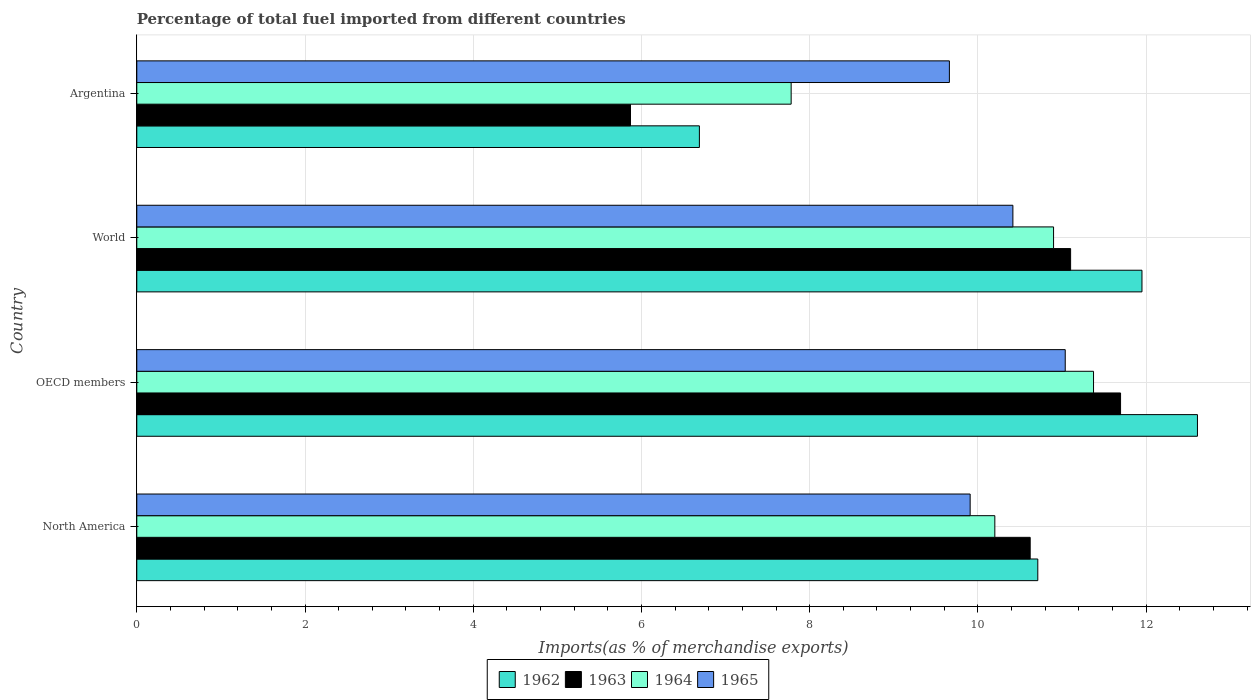How many groups of bars are there?
Your response must be concise. 4. Are the number of bars per tick equal to the number of legend labels?
Give a very brief answer. Yes. Are the number of bars on each tick of the Y-axis equal?
Provide a succinct answer. Yes. How many bars are there on the 1st tick from the top?
Provide a short and direct response. 4. How many bars are there on the 3rd tick from the bottom?
Keep it short and to the point. 4. What is the label of the 1st group of bars from the top?
Your answer should be very brief. Argentina. In how many cases, is the number of bars for a given country not equal to the number of legend labels?
Make the answer very short. 0. What is the percentage of imports to different countries in 1962 in OECD members?
Your answer should be very brief. 12.61. Across all countries, what is the maximum percentage of imports to different countries in 1962?
Your answer should be very brief. 12.61. Across all countries, what is the minimum percentage of imports to different countries in 1962?
Offer a terse response. 6.69. What is the total percentage of imports to different countries in 1965 in the graph?
Your answer should be very brief. 41.02. What is the difference between the percentage of imports to different countries in 1963 in OECD members and that in World?
Provide a succinct answer. 0.59. What is the difference between the percentage of imports to different countries in 1962 in Argentina and the percentage of imports to different countries in 1963 in World?
Keep it short and to the point. -4.41. What is the average percentage of imports to different countries in 1965 per country?
Offer a terse response. 10.26. What is the difference between the percentage of imports to different countries in 1964 and percentage of imports to different countries in 1965 in World?
Offer a very short reply. 0.48. In how many countries, is the percentage of imports to different countries in 1965 greater than 7.6 %?
Provide a short and direct response. 4. What is the ratio of the percentage of imports to different countries in 1962 in OECD members to that in World?
Keep it short and to the point. 1.06. Is the percentage of imports to different countries in 1962 in OECD members less than that in World?
Offer a terse response. No. What is the difference between the highest and the second highest percentage of imports to different countries in 1962?
Offer a very short reply. 0.66. What is the difference between the highest and the lowest percentage of imports to different countries in 1964?
Provide a short and direct response. 3.59. In how many countries, is the percentage of imports to different countries in 1965 greater than the average percentage of imports to different countries in 1965 taken over all countries?
Keep it short and to the point. 2. What does the 2nd bar from the top in North America represents?
Keep it short and to the point. 1964. What does the 3rd bar from the bottom in Argentina represents?
Your answer should be very brief. 1964. Is it the case that in every country, the sum of the percentage of imports to different countries in 1962 and percentage of imports to different countries in 1964 is greater than the percentage of imports to different countries in 1965?
Offer a very short reply. Yes. How many countries are there in the graph?
Offer a terse response. 4. What is the difference between two consecutive major ticks on the X-axis?
Keep it short and to the point. 2. Does the graph contain grids?
Your response must be concise. Yes. How many legend labels are there?
Keep it short and to the point. 4. What is the title of the graph?
Your response must be concise. Percentage of total fuel imported from different countries. Does "1984" appear as one of the legend labels in the graph?
Give a very brief answer. No. What is the label or title of the X-axis?
Ensure brevity in your answer.  Imports(as % of merchandise exports). What is the Imports(as % of merchandise exports) of 1962 in North America?
Offer a terse response. 10.71. What is the Imports(as % of merchandise exports) in 1963 in North America?
Offer a very short reply. 10.62. What is the Imports(as % of merchandise exports) in 1964 in North America?
Your response must be concise. 10.2. What is the Imports(as % of merchandise exports) of 1965 in North America?
Make the answer very short. 9.91. What is the Imports(as % of merchandise exports) in 1962 in OECD members?
Make the answer very short. 12.61. What is the Imports(as % of merchandise exports) in 1963 in OECD members?
Keep it short and to the point. 11.7. What is the Imports(as % of merchandise exports) in 1964 in OECD members?
Offer a very short reply. 11.37. What is the Imports(as % of merchandise exports) of 1965 in OECD members?
Your answer should be very brief. 11.04. What is the Imports(as % of merchandise exports) in 1962 in World?
Provide a short and direct response. 11.95. What is the Imports(as % of merchandise exports) in 1963 in World?
Give a very brief answer. 11.1. What is the Imports(as % of merchandise exports) in 1964 in World?
Provide a short and direct response. 10.9. What is the Imports(as % of merchandise exports) in 1965 in World?
Your answer should be very brief. 10.42. What is the Imports(as % of merchandise exports) in 1962 in Argentina?
Your answer should be compact. 6.69. What is the Imports(as % of merchandise exports) of 1963 in Argentina?
Your response must be concise. 5.87. What is the Imports(as % of merchandise exports) in 1964 in Argentina?
Provide a short and direct response. 7.78. What is the Imports(as % of merchandise exports) in 1965 in Argentina?
Provide a short and direct response. 9.66. Across all countries, what is the maximum Imports(as % of merchandise exports) of 1962?
Your answer should be compact. 12.61. Across all countries, what is the maximum Imports(as % of merchandise exports) in 1963?
Give a very brief answer. 11.7. Across all countries, what is the maximum Imports(as % of merchandise exports) in 1964?
Your answer should be compact. 11.37. Across all countries, what is the maximum Imports(as % of merchandise exports) of 1965?
Provide a succinct answer. 11.04. Across all countries, what is the minimum Imports(as % of merchandise exports) of 1962?
Provide a short and direct response. 6.69. Across all countries, what is the minimum Imports(as % of merchandise exports) of 1963?
Offer a terse response. 5.87. Across all countries, what is the minimum Imports(as % of merchandise exports) of 1964?
Your answer should be compact. 7.78. Across all countries, what is the minimum Imports(as % of merchandise exports) in 1965?
Your answer should be very brief. 9.66. What is the total Imports(as % of merchandise exports) in 1962 in the graph?
Offer a terse response. 41.96. What is the total Imports(as % of merchandise exports) in 1963 in the graph?
Ensure brevity in your answer.  39.29. What is the total Imports(as % of merchandise exports) in 1964 in the graph?
Provide a succinct answer. 40.25. What is the total Imports(as % of merchandise exports) of 1965 in the graph?
Your answer should be compact. 41.02. What is the difference between the Imports(as % of merchandise exports) of 1962 in North America and that in OECD members?
Keep it short and to the point. -1.9. What is the difference between the Imports(as % of merchandise exports) of 1963 in North America and that in OECD members?
Your answer should be very brief. -1.07. What is the difference between the Imports(as % of merchandise exports) in 1964 in North America and that in OECD members?
Offer a very short reply. -1.17. What is the difference between the Imports(as % of merchandise exports) in 1965 in North America and that in OECD members?
Your answer should be compact. -1.13. What is the difference between the Imports(as % of merchandise exports) in 1962 in North America and that in World?
Your answer should be very brief. -1.24. What is the difference between the Imports(as % of merchandise exports) in 1963 in North America and that in World?
Offer a very short reply. -0.48. What is the difference between the Imports(as % of merchandise exports) in 1964 in North America and that in World?
Provide a succinct answer. -0.7. What is the difference between the Imports(as % of merchandise exports) of 1965 in North America and that in World?
Keep it short and to the point. -0.51. What is the difference between the Imports(as % of merchandise exports) of 1962 in North America and that in Argentina?
Provide a short and direct response. 4.02. What is the difference between the Imports(as % of merchandise exports) in 1963 in North America and that in Argentina?
Ensure brevity in your answer.  4.75. What is the difference between the Imports(as % of merchandise exports) of 1964 in North America and that in Argentina?
Provide a succinct answer. 2.42. What is the difference between the Imports(as % of merchandise exports) in 1965 in North America and that in Argentina?
Offer a terse response. 0.25. What is the difference between the Imports(as % of merchandise exports) of 1962 in OECD members and that in World?
Give a very brief answer. 0.66. What is the difference between the Imports(as % of merchandise exports) of 1963 in OECD members and that in World?
Make the answer very short. 0.59. What is the difference between the Imports(as % of merchandise exports) in 1964 in OECD members and that in World?
Ensure brevity in your answer.  0.48. What is the difference between the Imports(as % of merchandise exports) in 1965 in OECD members and that in World?
Provide a succinct answer. 0.62. What is the difference between the Imports(as % of merchandise exports) of 1962 in OECD members and that in Argentina?
Keep it short and to the point. 5.92. What is the difference between the Imports(as % of merchandise exports) in 1963 in OECD members and that in Argentina?
Your answer should be compact. 5.83. What is the difference between the Imports(as % of merchandise exports) of 1964 in OECD members and that in Argentina?
Keep it short and to the point. 3.59. What is the difference between the Imports(as % of merchandise exports) in 1965 in OECD members and that in Argentina?
Give a very brief answer. 1.38. What is the difference between the Imports(as % of merchandise exports) in 1962 in World and that in Argentina?
Provide a succinct answer. 5.26. What is the difference between the Imports(as % of merchandise exports) in 1963 in World and that in Argentina?
Offer a terse response. 5.23. What is the difference between the Imports(as % of merchandise exports) of 1964 in World and that in Argentina?
Provide a short and direct response. 3.12. What is the difference between the Imports(as % of merchandise exports) of 1965 in World and that in Argentina?
Offer a terse response. 0.76. What is the difference between the Imports(as % of merchandise exports) in 1962 in North America and the Imports(as % of merchandise exports) in 1963 in OECD members?
Your answer should be very brief. -0.98. What is the difference between the Imports(as % of merchandise exports) in 1962 in North America and the Imports(as % of merchandise exports) in 1964 in OECD members?
Offer a very short reply. -0.66. What is the difference between the Imports(as % of merchandise exports) of 1962 in North America and the Imports(as % of merchandise exports) of 1965 in OECD members?
Your answer should be very brief. -0.33. What is the difference between the Imports(as % of merchandise exports) in 1963 in North America and the Imports(as % of merchandise exports) in 1964 in OECD members?
Keep it short and to the point. -0.75. What is the difference between the Imports(as % of merchandise exports) of 1963 in North America and the Imports(as % of merchandise exports) of 1965 in OECD members?
Make the answer very short. -0.42. What is the difference between the Imports(as % of merchandise exports) in 1964 in North America and the Imports(as % of merchandise exports) in 1965 in OECD members?
Your response must be concise. -0.84. What is the difference between the Imports(as % of merchandise exports) of 1962 in North America and the Imports(as % of merchandise exports) of 1963 in World?
Keep it short and to the point. -0.39. What is the difference between the Imports(as % of merchandise exports) in 1962 in North America and the Imports(as % of merchandise exports) in 1964 in World?
Your answer should be very brief. -0.19. What is the difference between the Imports(as % of merchandise exports) in 1962 in North America and the Imports(as % of merchandise exports) in 1965 in World?
Provide a succinct answer. 0.3. What is the difference between the Imports(as % of merchandise exports) in 1963 in North America and the Imports(as % of merchandise exports) in 1964 in World?
Your answer should be very brief. -0.28. What is the difference between the Imports(as % of merchandise exports) in 1963 in North America and the Imports(as % of merchandise exports) in 1965 in World?
Offer a very short reply. 0.21. What is the difference between the Imports(as % of merchandise exports) of 1964 in North America and the Imports(as % of merchandise exports) of 1965 in World?
Your answer should be very brief. -0.21. What is the difference between the Imports(as % of merchandise exports) in 1962 in North America and the Imports(as % of merchandise exports) in 1963 in Argentina?
Offer a very short reply. 4.84. What is the difference between the Imports(as % of merchandise exports) of 1962 in North America and the Imports(as % of merchandise exports) of 1964 in Argentina?
Give a very brief answer. 2.93. What is the difference between the Imports(as % of merchandise exports) in 1962 in North America and the Imports(as % of merchandise exports) in 1965 in Argentina?
Your answer should be very brief. 1.05. What is the difference between the Imports(as % of merchandise exports) in 1963 in North America and the Imports(as % of merchandise exports) in 1964 in Argentina?
Your answer should be very brief. 2.84. What is the difference between the Imports(as % of merchandise exports) in 1963 in North America and the Imports(as % of merchandise exports) in 1965 in Argentina?
Your response must be concise. 0.96. What is the difference between the Imports(as % of merchandise exports) of 1964 in North America and the Imports(as % of merchandise exports) of 1965 in Argentina?
Provide a short and direct response. 0.54. What is the difference between the Imports(as % of merchandise exports) in 1962 in OECD members and the Imports(as % of merchandise exports) in 1963 in World?
Your response must be concise. 1.51. What is the difference between the Imports(as % of merchandise exports) of 1962 in OECD members and the Imports(as % of merchandise exports) of 1964 in World?
Make the answer very short. 1.71. What is the difference between the Imports(as % of merchandise exports) of 1962 in OECD members and the Imports(as % of merchandise exports) of 1965 in World?
Your response must be concise. 2.19. What is the difference between the Imports(as % of merchandise exports) of 1963 in OECD members and the Imports(as % of merchandise exports) of 1964 in World?
Your response must be concise. 0.8. What is the difference between the Imports(as % of merchandise exports) of 1963 in OECD members and the Imports(as % of merchandise exports) of 1965 in World?
Your answer should be compact. 1.28. What is the difference between the Imports(as % of merchandise exports) in 1964 in OECD members and the Imports(as % of merchandise exports) in 1965 in World?
Give a very brief answer. 0.96. What is the difference between the Imports(as % of merchandise exports) in 1962 in OECD members and the Imports(as % of merchandise exports) in 1963 in Argentina?
Your answer should be compact. 6.74. What is the difference between the Imports(as % of merchandise exports) in 1962 in OECD members and the Imports(as % of merchandise exports) in 1964 in Argentina?
Make the answer very short. 4.83. What is the difference between the Imports(as % of merchandise exports) of 1962 in OECD members and the Imports(as % of merchandise exports) of 1965 in Argentina?
Provide a succinct answer. 2.95. What is the difference between the Imports(as % of merchandise exports) in 1963 in OECD members and the Imports(as % of merchandise exports) in 1964 in Argentina?
Make the answer very short. 3.92. What is the difference between the Imports(as % of merchandise exports) of 1963 in OECD members and the Imports(as % of merchandise exports) of 1965 in Argentina?
Offer a very short reply. 2.04. What is the difference between the Imports(as % of merchandise exports) of 1964 in OECD members and the Imports(as % of merchandise exports) of 1965 in Argentina?
Your response must be concise. 1.71. What is the difference between the Imports(as % of merchandise exports) of 1962 in World and the Imports(as % of merchandise exports) of 1963 in Argentina?
Your answer should be compact. 6.08. What is the difference between the Imports(as % of merchandise exports) of 1962 in World and the Imports(as % of merchandise exports) of 1964 in Argentina?
Offer a very short reply. 4.17. What is the difference between the Imports(as % of merchandise exports) in 1962 in World and the Imports(as % of merchandise exports) in 1965 in Argentina?
Keep it short and to the point. 2.29. What is the difference between the Imports(as % of merchandise exports) in 1963 in World and the Imports(as % of merchandise exports) in 1964 in Argentina?
Keep it short and to the point. 3.32. What is the difference between the Imports(as % of merchandise exports) of 1963 in World and the Imports(as % of merchandise exports) of 1965 in Argentina?
Make the answer very short. 1.44. What is the difference between the Imports(as % of merchandise exports) in 1964 in World and the Imports(as % of merchandise exports) in 1965 in Argentina?
Your response must be concise. 1.24. What is the average Imports(as % of merchandise exports) in 1962 per country?
Provide a short and direct response. 10.49. What is the average Imports(as % of merchandise exports) of 1963 per country?
Your answer should be compact. 9.82. What is the average Imports(as % of merchandise exports) of 1964 per country?
Your response must be concise. 10.06. What is the average Imports(as % of merchandise exports) in 1965 per country?
Keep it short and to the point. 10.26. What is the difference between the Imports(as % of merchandise exports) of 1962 and Imports(as % of merchandise exports) of 1963 in North America?
Your answer should be very brief. 0.09. What is the difference between the Imports(as % of merchandise exports) of 1962 and Imports(as % of merchandise exports) of 1964 in North America?
Your response must be concise. 0.51. What is the difference between the Imports(as % of merchandise exports) in 1962 and Imports(as % of merchandise exports) in 1965 in North America?
Give a very brief answer. 0.8. What is the difference between the Imports(as % of merchandise exports) of 1963 and Imports(as % of merchandise exports) of 1964 in North America?
Provide a succinct answer. 0.42. What is the difference between the Imports(as % of merchandise exports) in 1963 and Imports(as % of merchandise exports) in 1965 in North America?
Offer a very short reply. 0.71. What is the difference between the Imports(as % of merchandise exports) in 1964 and Imports(as % of merchandise exports) in 1965 in North America?
Keep it short and to the point. 0.29. What is the difference between the Imports(as % of merchandise exports) of 1962 and Imports(as % of merchandise exports) of 1963 in OECD members?
Your answer should be compact. 0.91. What is the difference between the Imports(as % of merchandise exports) in 1962 and Imports(as % of merchandise exports) in 1964 in OECD members?
Offer a terse response. 1.24. What is the difference between the Imports(as % of merchandise exports) of 1962 and Imports(as % of merchandise exports) of 1965 in OECD members?
Provide a short and direct response. 1.57. What is the difference between the Imports(as % of merchandise exports) of 1963 and Imports(as % of merchandise exports) of 1964 in OECD members?
Keep it short and to the point. 0.32. What is the difference between the Imports(as % of merchandise exports) of 1963 and Imports(as % of merchandise exports) of 1965 in OECD members?
Your response must be concise. 0.66. What is the difference between the Imports(as % of merchandise exports) in 1964 and Imports(as % of merchandise exports) in 1965 in OECD members?
Your response must be concise. 0.34. What is the difference between the Imports(as % of merchandise exports) in 1962 and Imports(as % of merchandise exports) in 1963 in World?
Give a very brief answer. 0.85. What is the difference between the Imports(as % of merchandise exports) of 1962 and Imports(as % of merchandise exports) of 1964 in World?
Your answer should be very brief. 1.05. What is the difference between the Imports(as % of merchandise exports) in 1962 and Imports(as % of merchandise exports) in 1965 in World?
Provide a succinct answer. 1.53. What is the difference between the Imports(as % of merchandise exports) in 1963 and Imports(as % of merchandise exports) in 1964 in World?
Your answer should be compact. 0.2. What is the difference between the Imports(as % of merchandise exports) in 1963 and Imports(as % of merchandise exports) in 1965 in World?
Provide a short and direct response. 0.69. What is the difference between the Imports(as % of merchandise exports) of 1964 and Imports(as % of merchandise exports) of 1965 in World?
Offer a terse response. 0.48. What is the difference between the Imports(as % of merchandise exports) in 1962 and Imports(as % of merchandise exports) in 1963 in Argentina?
Ensure brevity in your answer.  0.82. What is the difference between the Imports(as % of merchandise exports) in 1962 and Imports(as % of merchandise exports) in 1964 in Argentina?
Ensure brevity in your answer.  -1.09. What is the difference between the Imports(as % of merchandise exports) in 1962 and Imports(as % of merchandise exports) in 1965 in Argentina?
Provide a succinct answer. -2.97. What is the difference between the Imports(as % of merchandise exports) of 1963 and Imports(as % of merchandise exports) of 1964 in Argentina?
Offer a terse response. -1.91. What is the difference between the Imports(as % of merchandise exports) in 1963 and Imports(as % of merchandise exports) in 1965 in Argentina?
Your answer should be compact. -3.79. What is the difference between the Imports(as % of merchandise exports) of 1964 and Imports(as % of merchandise exports) of 1965 in Argentina?
Keep it short and to the point. -1.88. What is the ratio of the Imports(as % of merchandise exports) of 1962 in North America to that in OECD members?
Make the answer very short. 0.85. What is the ratio of the Imports(as % of merchandise exports) of 1963 in North America to that in OECD members?
Offer a very short reply. 0.91. What is the ratio of the Imports(as % of merchandise exports) of 1964 in North America to that in OECD members?
Offer a very short reply. 0.9. What is the ratio of the Imports(as % of merchandise exports) in 1965 in North America to that in OECD members?
Make the answer very short. 0.9. What is the ratio of the Imports(as % of merchandise exports) of 1962 in North America to that in World?
Offer a terse response. 0.9. What is the ratio of the Imports(as % of merchandise exports) in 1963 in North America to that in World?
Your answer should be compact. 0.96. What is the ratio of the Imports(as % of merchandise exports) in 1964 in North America to that in World?
Keep it short and to the point. 0.94. What is the ratio of the Imports(as % of merchandise exports) in 1965 in North America to that in World?
Give a very brief answer. 0.95. What is the ratio of the Imports(as % of merchandise exports) in 1962 in North America to that in Argentina?
Your response must be concise. 1.6. What is the ratio of the Imports(as % of merchandise exports) in 1963 in North America to that in Argentina?
Give a very brief answer. 1.81. What is the ratio of the Imports(as % of merchandise exports) of 1964 in North America to that in Argentina?
Your answer should be compact. 1.31. What is the ratio of the Imports(as % of merchandise exports) in 1965 in North America to that in Argentina?
Offer a very short reply. 1.03. What is the ratio of the Imports(as % of merchandise exports) of 1962 in OECD members to that in World?
Provide a succinct answer. 1.06. What is the ratio of the Imports(as % of merchandise exports) in 1963 in OECD members to that in World?
Give a very brief answer. 1.05. What is the ratio of the Imports(as % of merchandise exports) in 1964 in OECD members to that in World?
Provide a succinct answer. 1.04. What is the ratio of the Imports(as % of merchandise exports) of 1965 in OECD members to that in World?
Your answer should be very brief. 1.06. What is the ratio of the Imports(as % of merchandise exports) of 1962 in OECD members to that in Argentina?
Give a very brief answer. 1.89. What is the ratio of the Imports(as % of merchandise exports) of 1963 in OECD members to that in Argentina?
Your response must be concise. 1.99. What is the ratio of the Imports(as % of merchandise exports) of 1964 in OECD members to that in Argentina?
Ensure brevity in your answer.  1.46. What is the ratio of the Imports(as % of merchandise exports) in 1965 in OECD members to that in Argentina?
Your response must be concise. 1.14. What is the ratio of the Imports(as % of merchandise exports) in 1962 in World to that in Argentina?
Keep it short and to the point. 1.79. What is the ratio of the Imports(as % of merchandise exports) of 1963 in World to that in Argentina?
Ensure brevity in your answer.  1.89. What is the ratio of the Imports(as % of merchandise exports) in 1964 in World to that in Argentina?
Offer a terse response. 1.4. What is the ratio of the Imports(as % of merchandise exports) of 1965 in World to that in Argentina?
Your answer should be compact. 1.08. What is the difference between the highest and the second highest Imports(as % of merchandise exports) of 1962?
Offer a terse response. 0.66. What is the difference between the highest and the second highest Imports(as % of merchandise exports) in 1963?
Give a very brief answer. 0.59. What is the difference between the highest and the second highest Imports(as % of merchandise exports) in 1964?
Offer a terse response. 0.48. What is the difference between the highest and the second highest Imports(as % of merchandise exports) in 1965?
Provide a succinct answer. 0.62. What is the difference between the highest and the lowest Imports(as % of merchandise exports) of 1962?
Provide a succinct answer. 5.92. What is the difference between the highest and the lowest Imports(as % of merchandise exports) of 1963?
Your response must be concise. 5.83. What is the difference between the highest and the lowest Imports(as % of merchandise exports) of 1964?
Provide a short and direct response. 3.59. What is the difference between the highest and the lowest Imports(as % of merchandise exports) in 1965?
Your answer should be very brief. 1.38. 